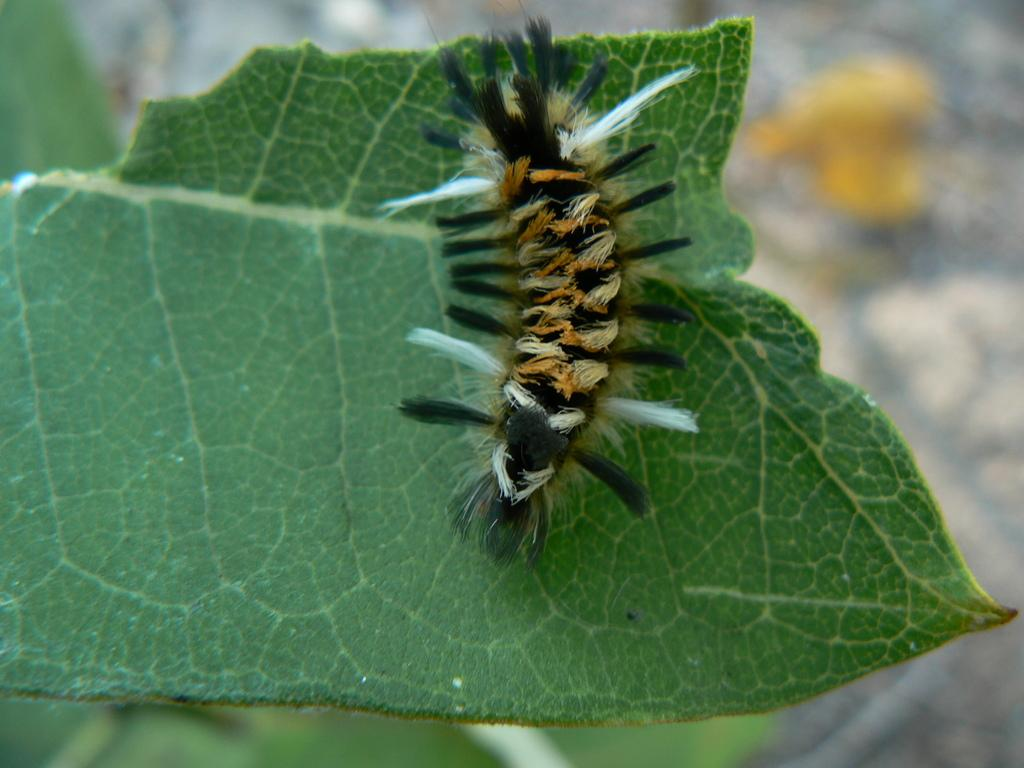What type of animal can be seen on a leaf in the image? There is an insect on a leaf in the image. What else is present on the surface in the image? There is an object on the surface in the image. What type of teeth can be seen in the image? There are no teeth present in the image. What trick is being performed by the insect in the image? There is no trick being performed by the insect in the image; it is simply sitting on a leaf. 